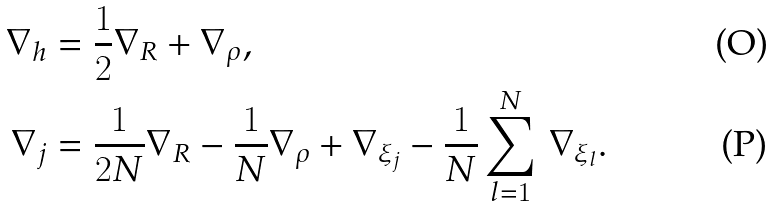Convert formula to latex. <formula><loc_0><loc_0><loc_500><loc_500>\nabla _ { h } & = \frac { 1 } { 2 } \nabla _ { R } + \nabla _ { \rho } , \\ \nabla _ { j } & = \frac { 1 } { 2 N } \nabla _ { R } - \frac { 1 } { N } \nabla _ { \rho } + \nabla _ { \xi _ { j } } - \frac { 1 } { N } \sum _ { l = 1 } ^ { N } \, \nabla _ { \xi _ { l } } .</formula> 